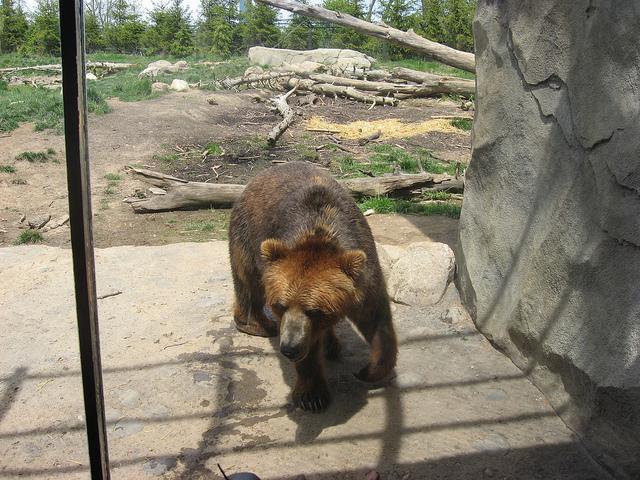How many bears are there?
Give a very brief answer. 1. 